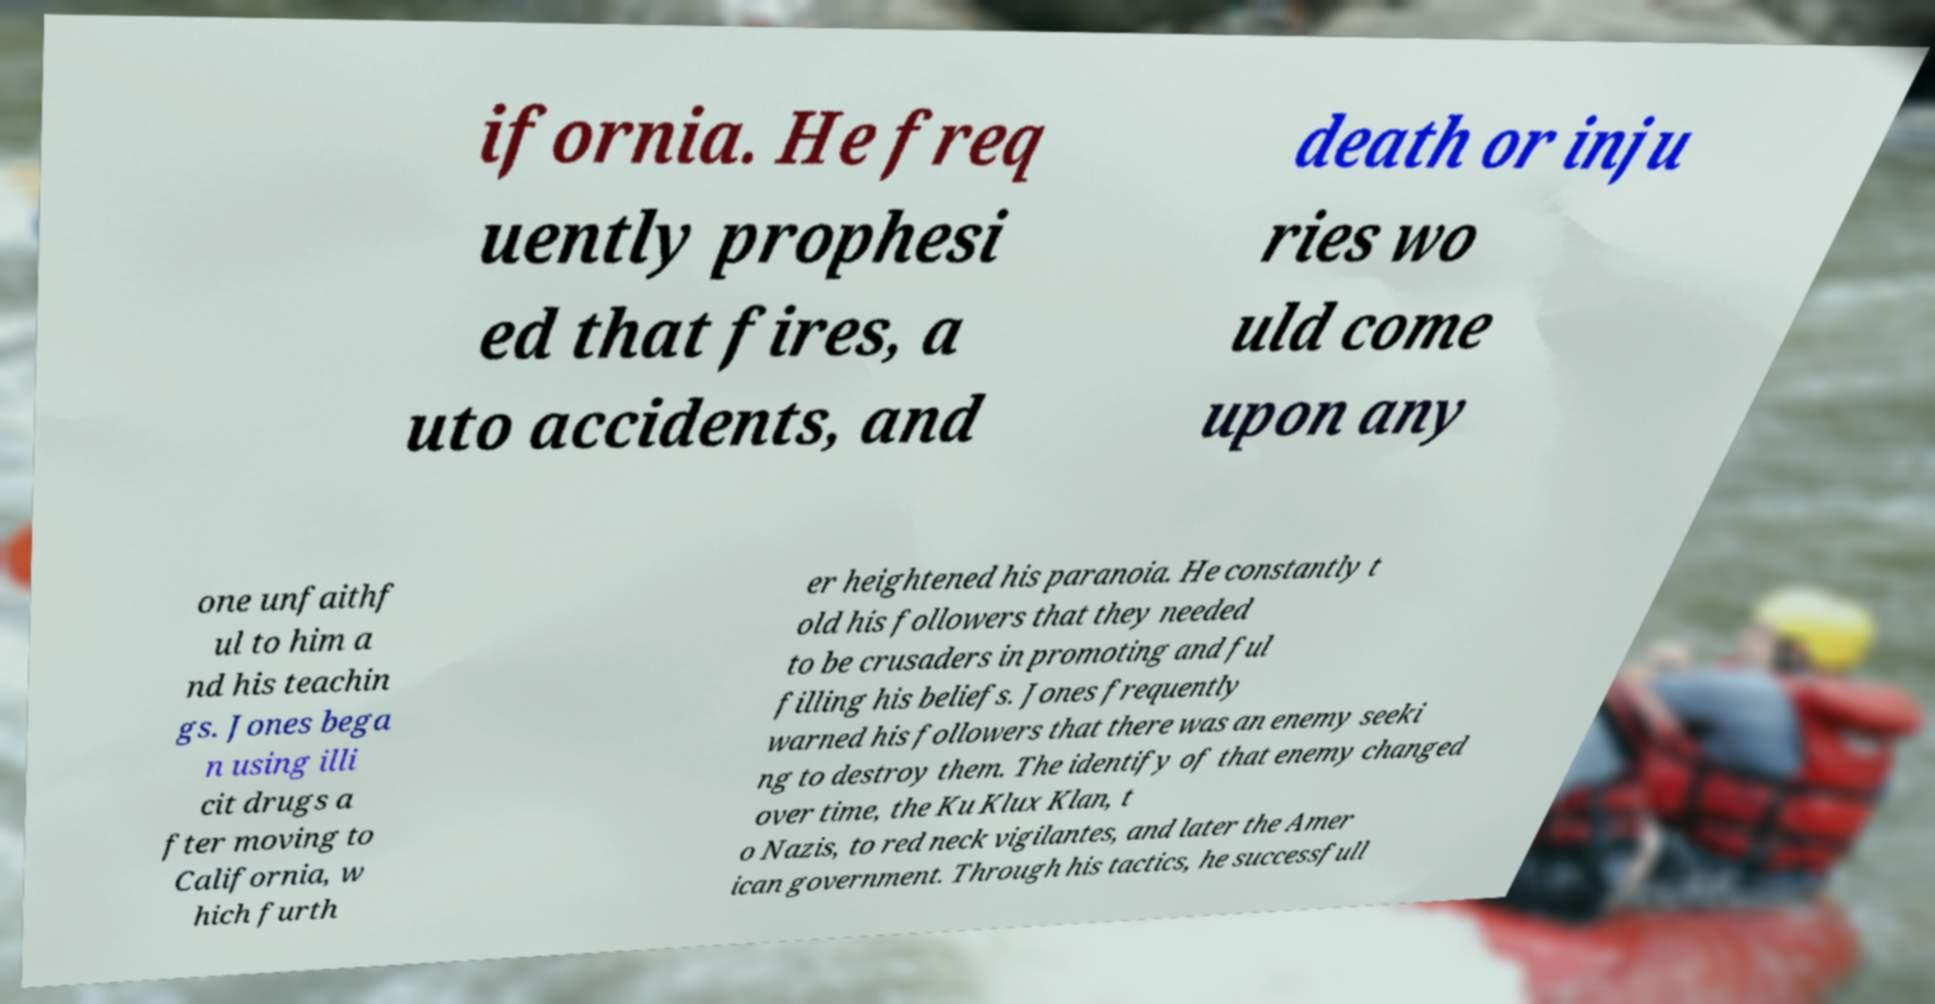Can you accurately transcribe the text from the provided image for me? ifornia. He freq uently prophesi ed that fires, a uto accidents, and death or inju ries wo uld come upon any one unfaithf ul to him a nd his teachin gs. Jones bega n using illi cit drugs a fter moving to California, w hich furth er heightened his paranoia. He constantly t old his followers that they needed to be crusaders in promoting and ful filling his beliefs. Jones frequently warned his followers that there was an enemy seeki ng to destroy them. The identify of that enemy changed over time, the Ku Klux Klan, t o Nazis, to red neck vigilantes, and later the Amer ican government. Through his tactics, he successfull 